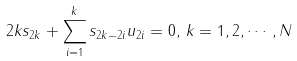<formula> <loc_0><loc_0><loc_500><loc_500>2 k s _ { 2 k } + \sum _ { i = 1 } ^ { k } s _ { 2 k - 2 i } u _ { 2 i } = 0 , \, k = 1 , 2 , \cdots , N</formula> 